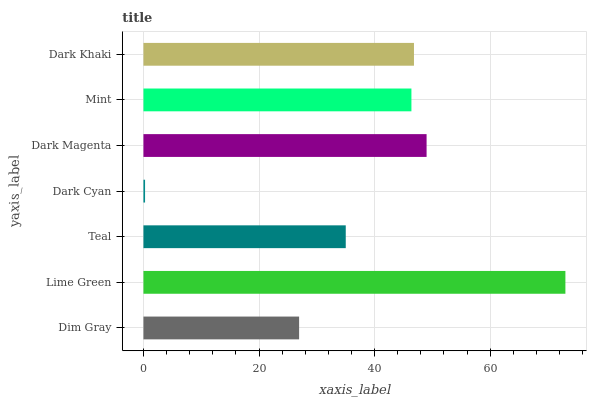Is Dark Cyan the minimum?
Answer yes or no. Yes. Is Lime Green the maximum?
Answer yes or no. Yes. Is Teal the minimum?
Answer yes or no. No. Is Teal the maximum?
Answer yes or no. No. Is Lime Green greater than Teal?
Answer yes or no. Yes. Is Teal less than Lime Green?
Answer yes or no. Yes. Is Teal greater than Lime Green?
Answer yes or no. No. Is Lime Green less than Teal?
Answer yes or no. No. Is Mint the high median?
Answer yes or no. Yes. Is Mint the low median?
Answer yes or no. Yes. Is Dark Cyan the high median?
Answer yes or no. No. Is Dark Magenta the low median?
Answer yes or no. No. 